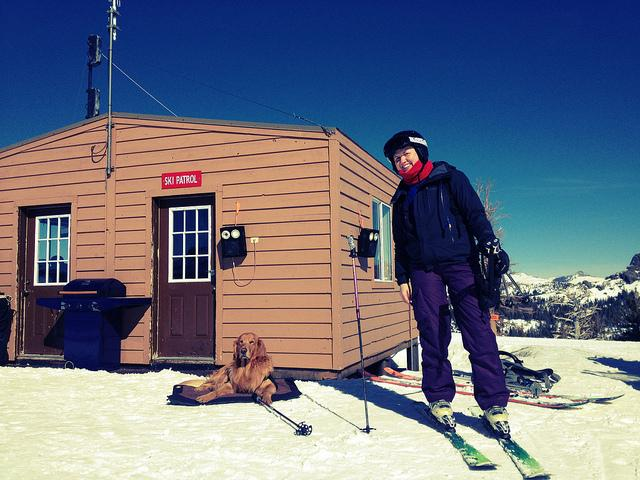What type of sign is on the building?

Choices:
A) directional
B) informational
C) brand
D) warning informational 